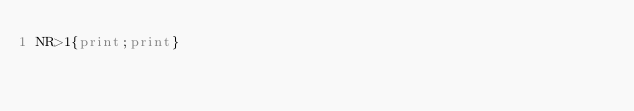<code> <loc_0><loc_0><loc_500><loc_500><_Awk_>NR>1{print;print}</code> 